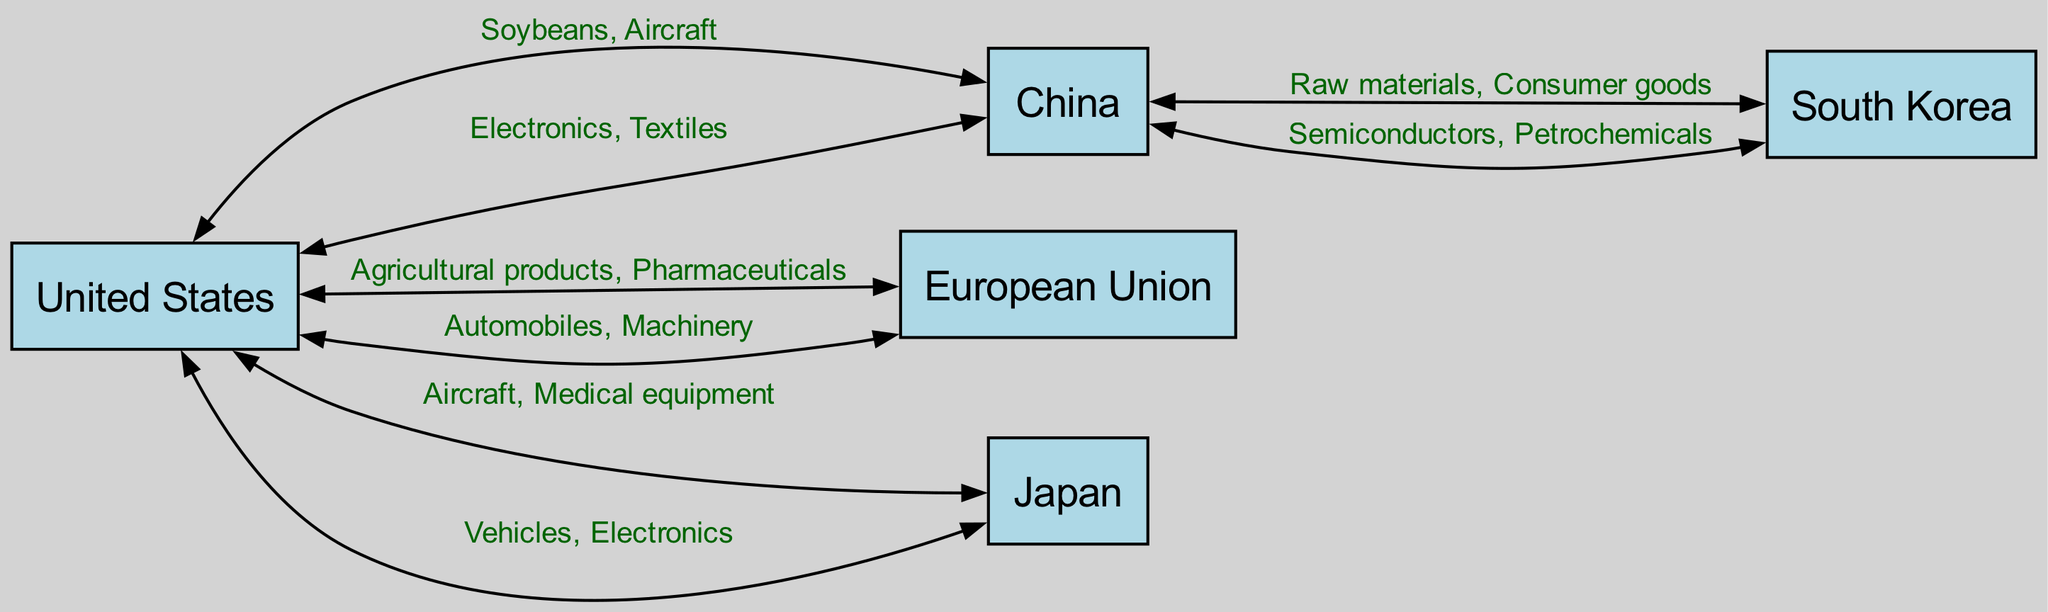What is the total number of countries represented in the diagram? The diagram includes five distinct countries listed as nodes: United States, China, European Union, Japan, and South Korea. Therefore, counting these gives a total of five countries.
Answer: 5 Which country exports Soybeans and Aircraft? According to the directed edges in the diagram, the United States exports both Soybeans and Aircraft to China. This is clearly indicated in the respective edge label in the flow.
Answer: United States How many goods are exported from the United States to Japan? The directed edge from the United States to Japan shows two goods listed: Aircraft and Medical equipment. Therefore, there are two goods being exported.
Answer: 2 Which country imports Electronics and Textiles? Looking at the directed edge from China to the United States, these two goods (Electronics and Textiles) are indicated as what China exports to the United States. Hence, the United States imports these goods.
Answer: United States What is the relationship between South Korea and China in terms of goods flow? The diagram shows an edge going from South Korea to China with the label stating the exported goods are Semiconductors and Petrochemicals. This establishes a direct flow of goods from South Korea to China.
Answer: Exports Semiconductors and Petrochemicals Which country is involved in the most significant number of exports indicated in the diagram? By analyzing the diagram, the United States shows a directed flow of goods to multiple countries (China, European Union, Japan), totaling four export relationships. This indicates that the United States is the country with the most significant number of export connections presented in the diagram.
Answer: United States What goods does China export to South Korea? The directed edge from China to South Korea specifies that the goods being exported are Raw materials and Consumer goods. This details the specific exports from China to South Korea.
Answer: Raw materials, Consumer goods From which country does the European Union receive automobiles and machinery? The diagram illustrates that the European Union imports automobiles and machinery from the United States, as indicated by the directed edge from the United States to the European Union.
Answer: United States How many edges are shown in the trade flow diagram? By counting the directed edges, we find that there are eight connections listed in the data between the various countries, signifying the flow of goods and services. Thus, there are eight edges in total.
Answer: 8 